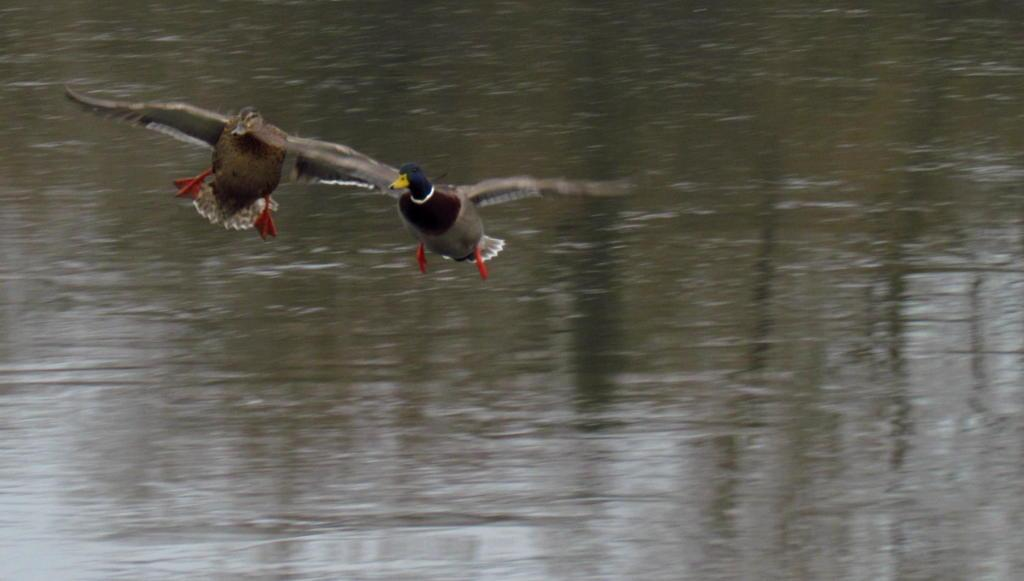How many birds are in the image? There are two birds in the image. What are the birds doing in the image? The birds are flying on the water. Can you describe the appearance of the first bird? The first bird has a blue neck and a yellow beak. What language are the birds speaking in the image? Birds do not speak human languages, so it is not possible to determine the language they might be speaking in the image. 